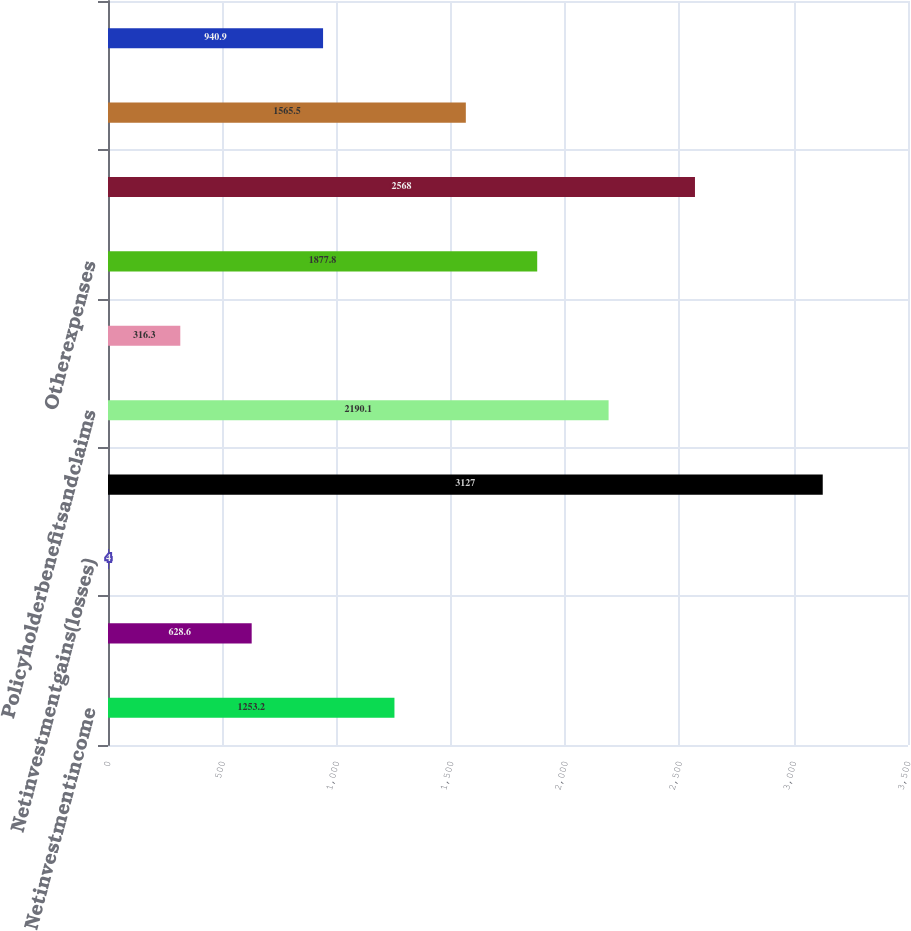Convert chart to OTSL. <chart><loc_0><loc_0><loc_500><loc_500><bar_chart><fcel>Netinvestmentincome<fcel>Otherrevenues<fcel>Netinvestmentgains(losses)<fcel>Totalrevenues<fcel>Policyholderbenefitsandclaims<fcel>Policyholderdividends<fcel>Otherexpenses<fcel>Totalexpenses<fcel>Unnamed: 8<fcel>Provisionforincometax<nl><fcel>1253.2<fcel>628.6<fcel>4<fcel>3127<fcel>2190.1<fcel>316.3<fcel>1877.8<fcel>2568<fcel>1565.5<fcel>940.9<nl></chart> 